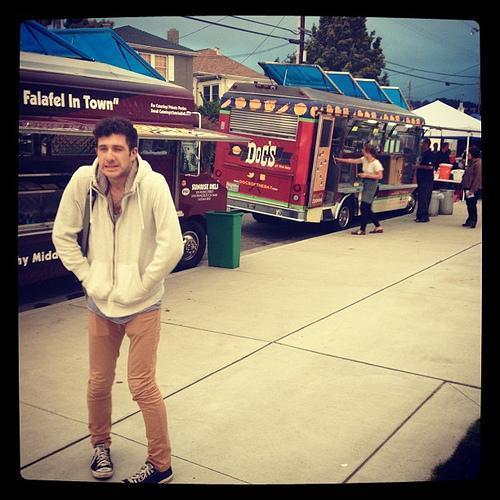How many food trucks are pictured?
Give a very brief answer. 2. 